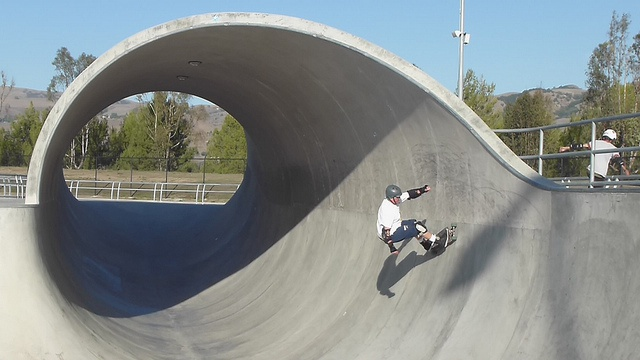Describe the objects in this image and their specific colors. I can see people in lightblue, white, gray, darkgray, and black tones, people in lightblue, lightgray, gray, darkgray, and black tones, and skateboard in lightblue, gray, darkgray, black, and lightgray tones in this image. 